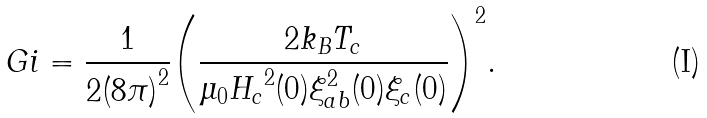Convert formula to latex. <formula><loc_0><loc_0><loc_500><loc_500>G i = \frac { 1 } { 2 { ( 8 \pi ) } ^ { 2 } } { \left ( \frac { 2 k _ { B } T _ { c } } { \mu _ { 0 } { H _ { c } } ^ { 2 } ( 0 ) \xi _ { a b } ^ { 2 } ( 0 ) \xi _ { c } ( 0 ) } \right ) } ^ { 2 } .</formula> 